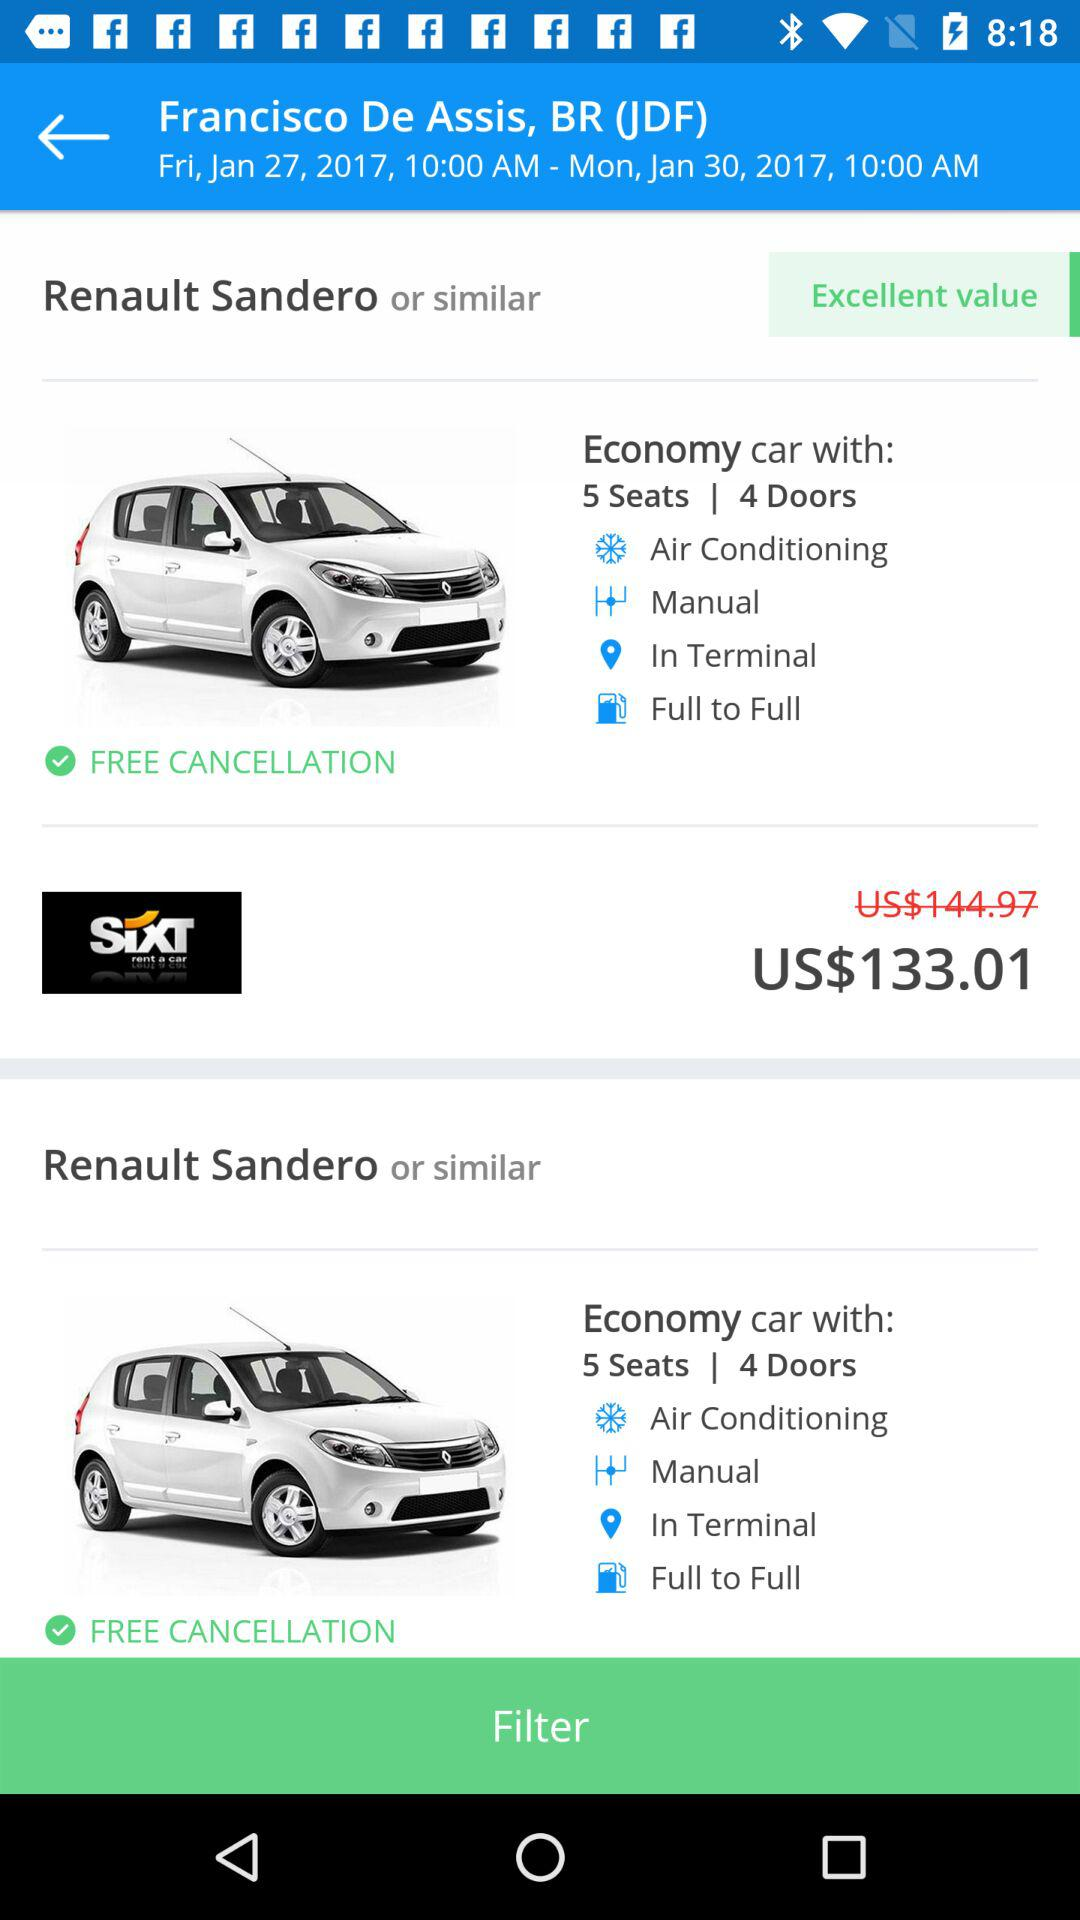What is the transmission system? The transmission system is manual. 